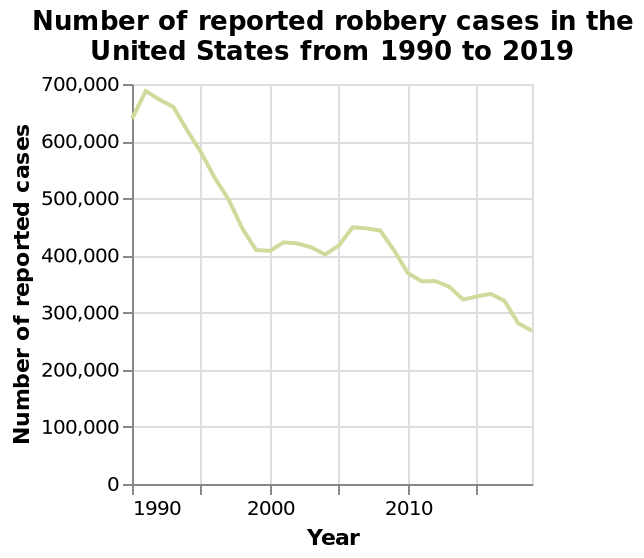<image>
Offer a thorough analysis of the image. The graph shows that the number of robberies  in the us from 1990 to 2019 had decreased from 650,000 to 275,000. There were slight increases over time but a general halving of the original number. 